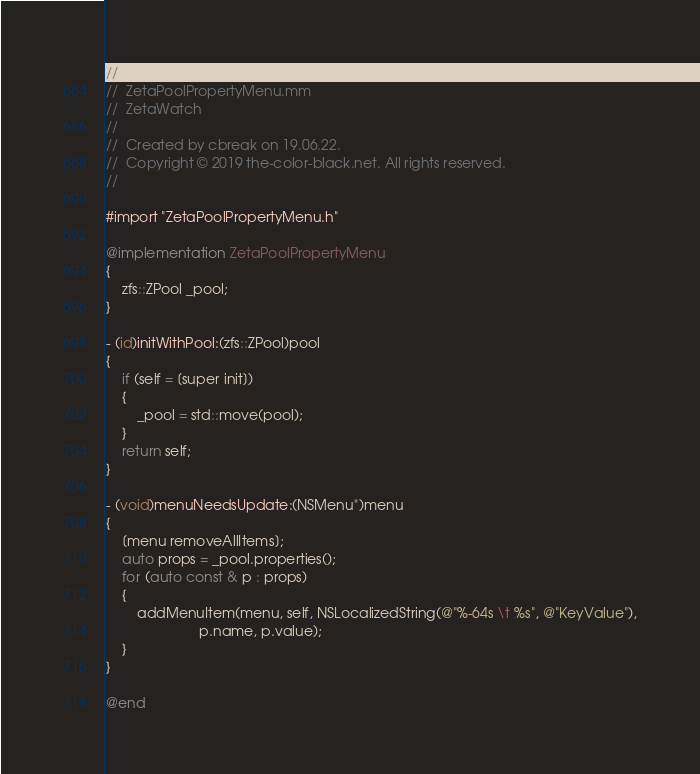<code> <loc_0><loc_0><loc_500><loc_500><_ObjectiveC_>//
//  ZetaPoolPropertyMenu.mm
//  ZetaWatch
//
//  Created by cbreak on 19.06.22.
//  Copyright © 2019 the-color-black.net. All rights reserved.
//

#import "ZetaPoolPropertyMenu.h"

@implementation ZetaPoolPropertyMenu
{
	zfs::ZPool _pool;
}

- (id)initWithPool:(zfs::ZPool)pool
{
	if (self = [super init])
	{
		_pool = std::move(pool);
	}
	return self;
}

- (void)menuNeedsUpdate:(NSMenu*)menu
{
	[menu removeAllItems];
	auto props = _pool.properties();
	for (auto const & p : props)
	{
		addMenuItem(menu, self, NSLocalizedString(@"%-64s \t %s", @"KeyValue"),
						p.name, p.value);
	}
}

@end
</code> 